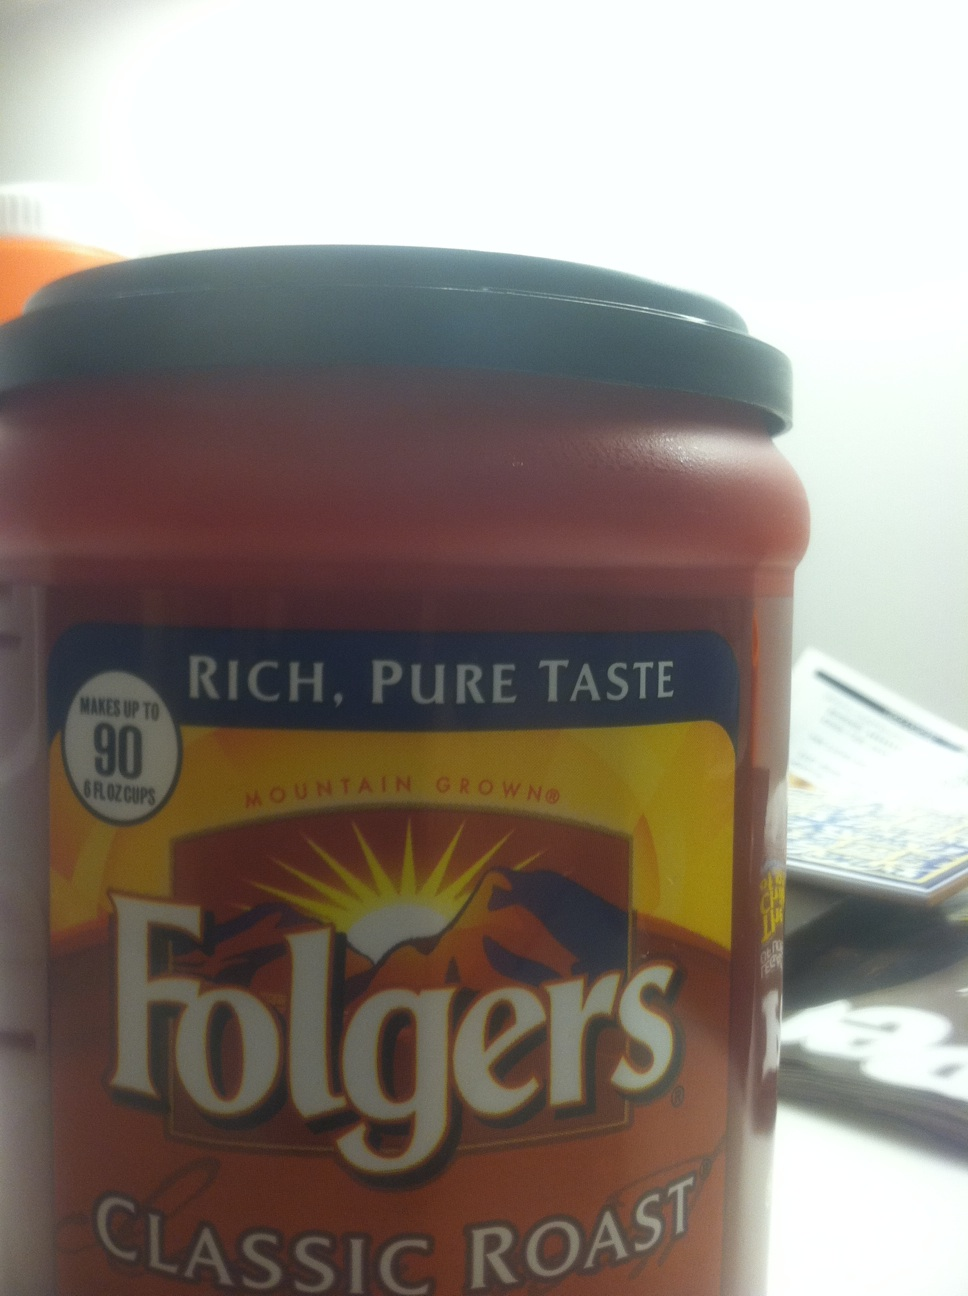I see that this container makes up to 90 cups. How large is the container? The label on the container states that it can make up to 90 cups, which typically means it contains enough ground coffee to do so when using the recommended amount per cup. This container size is usually around 10.3 to 11.3 ounces (292 to 320 grams) of ground coffee, allowing you to enjoy multiple servings from a single purchase. 